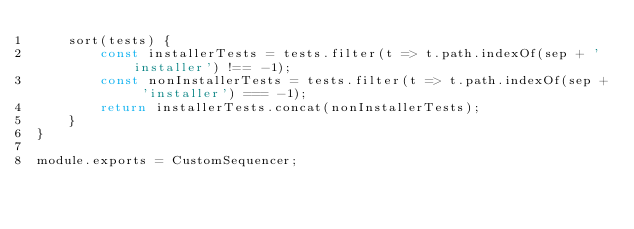Convert code to text. <code><loc_0><loc_0><loc_500><loc_500><_JavaScript_>    sort(tests) {
        const installerTests = tests.filter(t => t.path.indexOf(sep + 'installer') !== -1);
        const nonInstallerTests = tests.filter(t => t.path.indexOf(sep + 'installer') === -1);
        return installerTests.concat(nonInstallerTests);
    }
}

module.exports = CustomSequencer;</code> 